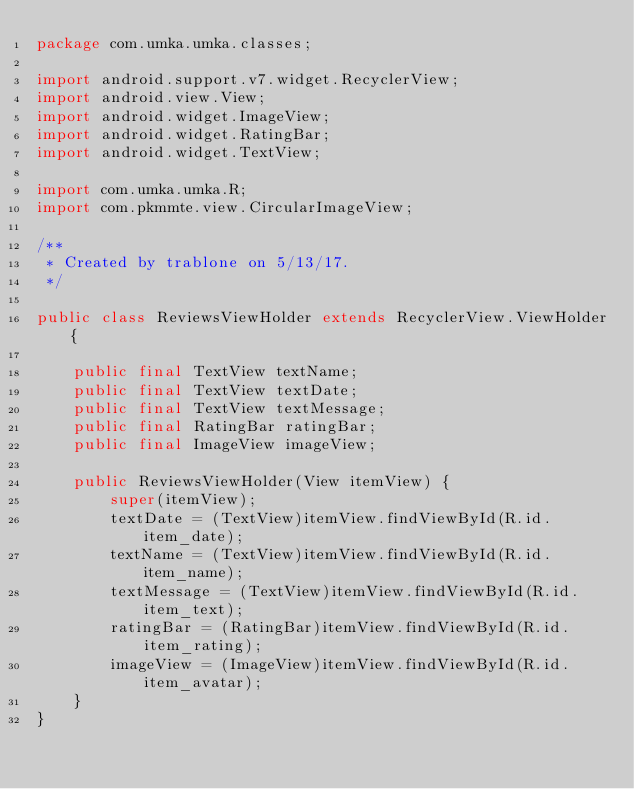<code> <loc_0><loc_0><loc_500><loc_500><_Java_>package com.umka.umka.classes;

import android.support.v7.widget.RecyclerView;
import android.view.View;
import android.widget.ImageView;
import android.widget.RatingBar;
import android.widget.TextView;

import com.umka.umka.R;
import com.pkmmte.view.CircularImageView;

/**
 * Created by trablone on 5/13/17.
 */

public class ReviewsViewHolder extends RecyclerView.ViewHolder{

    public final TextView textName;
    public final TextView textDate;
    public final TextView textMessage;
    public final RatingBar ratingBar;
    public final ImageView imageView;

    public ReviewsViewHolder(View itemView) {
        super(itemView);
        textDate = (TextView)itemView.findViewById(R.id.item_date);
        textName = (TextView)itemView.findViewById(R.id.item_name);
        textMessage = (TextView)itemView.findViewById(R.id.item_text);
        ratingBar = (RatingBar)itemView.findViewById(R.id.item_rating);
        imageView = (ImageView)itemView.findViewById(R.id.item_avatar);
    }
}
</code> 